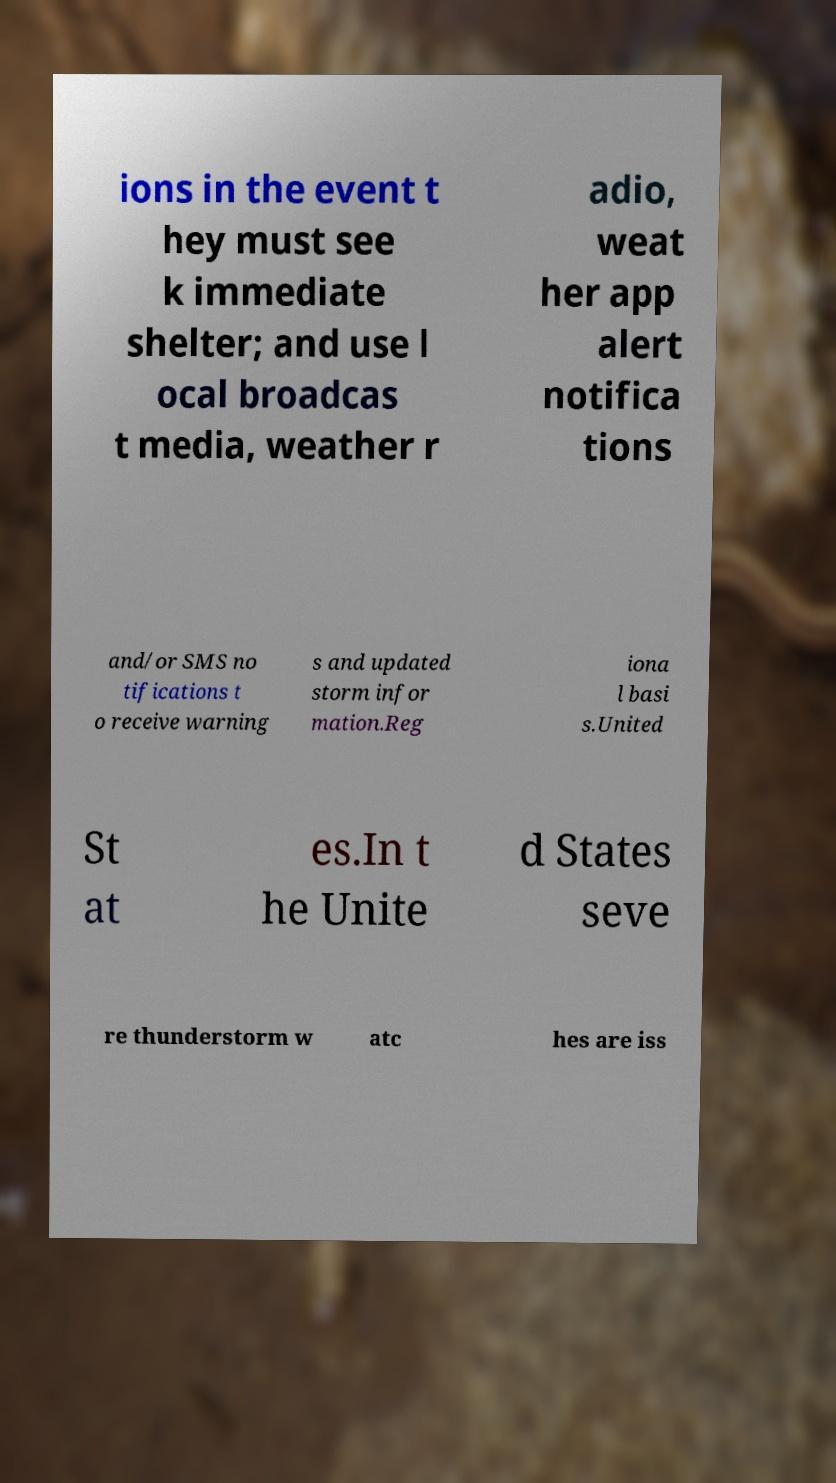Please identify and transcribe the text found in this image. ions in the event t hey must see k immediate shelter; and use l ocal broadcas t media, weather r adio, weat her app alert notifica tions and/or SMS no tifications t o receive warning s and updated storm infor mation.Reg iona l basi s.United St at es.In t he Unite d States seve re thunderstorm w atc hes are iss 